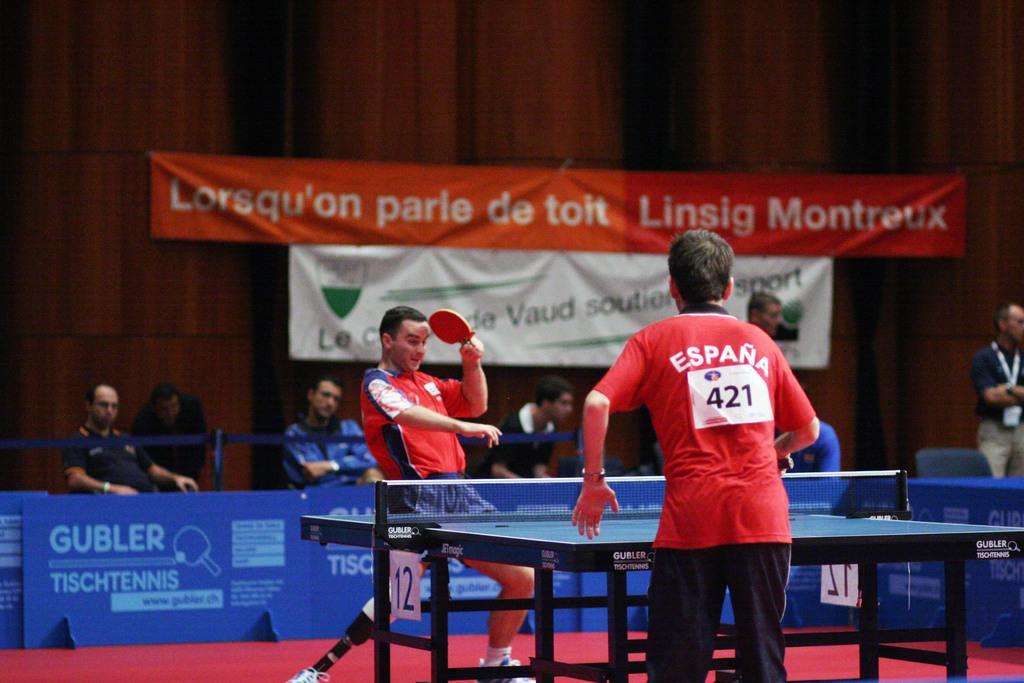Provide a one-sentence caption for the provided image. Number 421 plays ping pong with an opponent on table 12. 